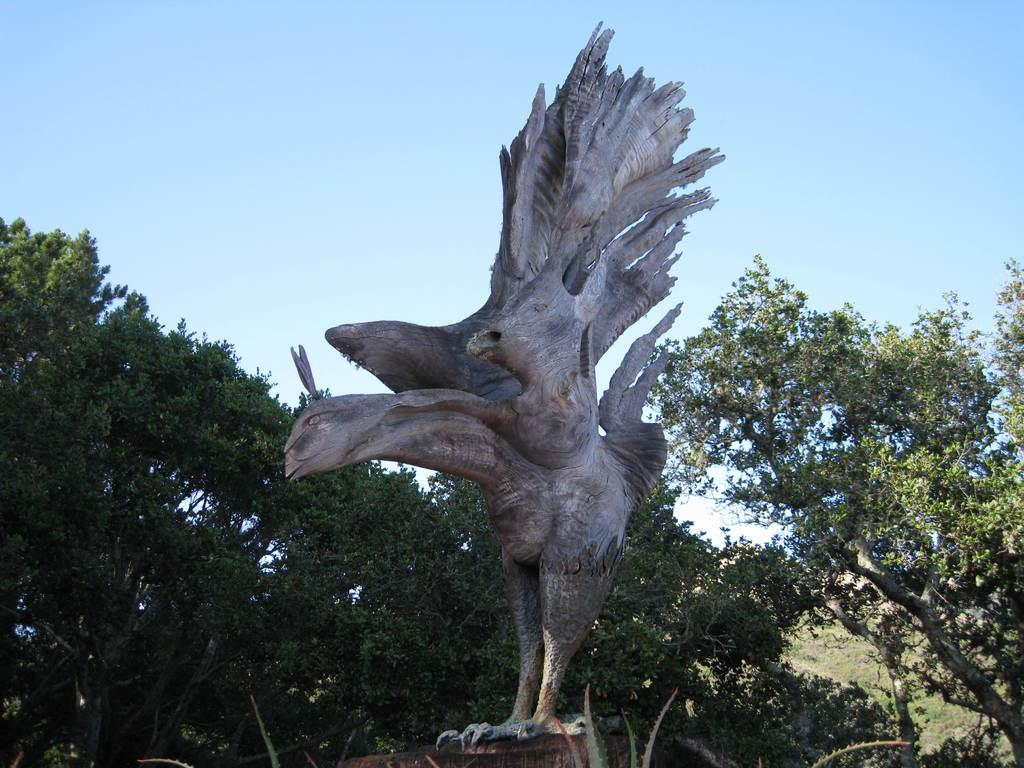What is the main subject in the middle of the image? There is a statue in the middle of the image. What can be seen in the background of the image? There are trees in the background of the image. What type of milk is being poured on the statue in the image? There is no milk being poured on the statue in the image; it is a static statue surrounded by trees. 